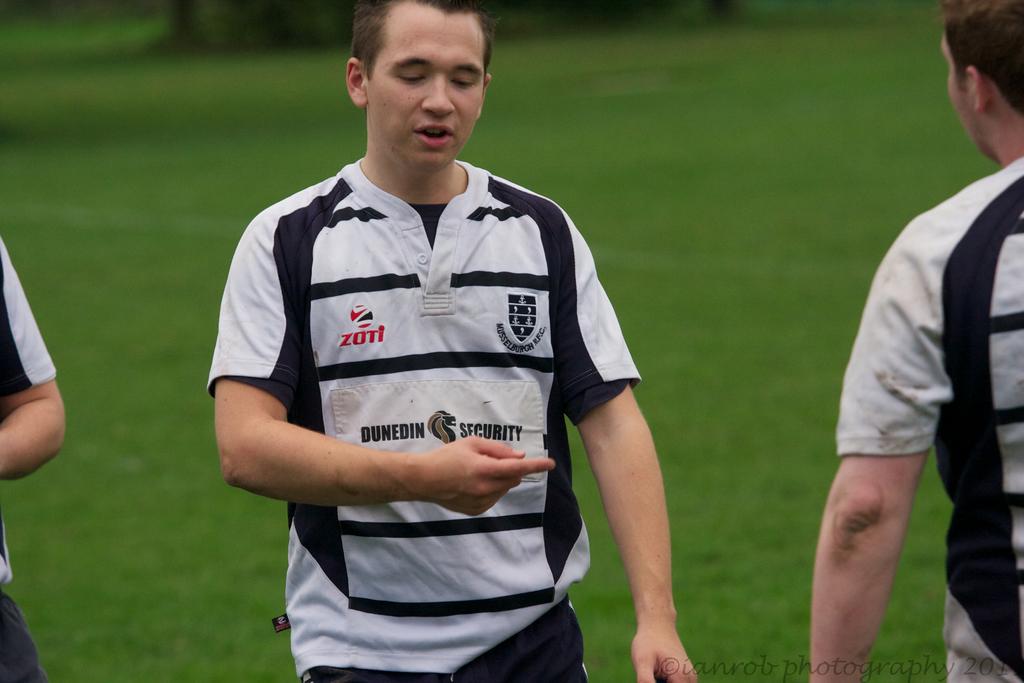What is the name of the photographer on the bottom right?
Ensure brevity in your answer.  Ianrob. What security company sponsors this team?
Your answer should be compact. Dunedin. 